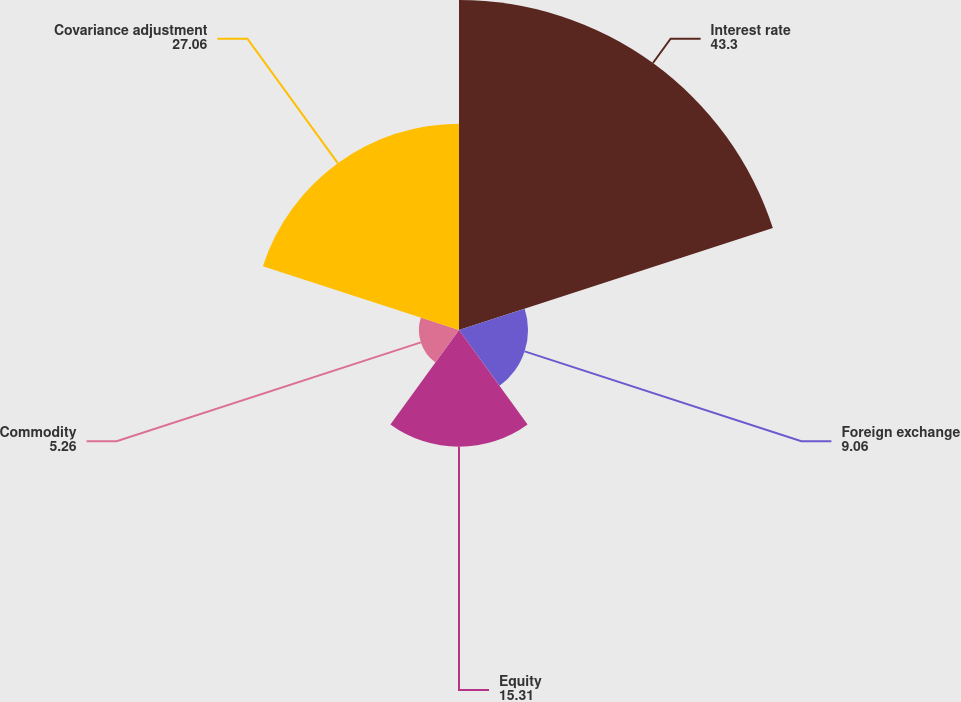<chart> <loc_0><loc_0><loc_500><loc_500><pie_chart><fcel>Interest rate<fcel>Foreign exchange<fcel>Equity<fcel>Commodity<fcel>Covariance adjustment<nl><fcel>43.3%<fcel>9.06%<fcel>15.31%<fcel>5.26%<fcel>27.06%<nl></chart> 